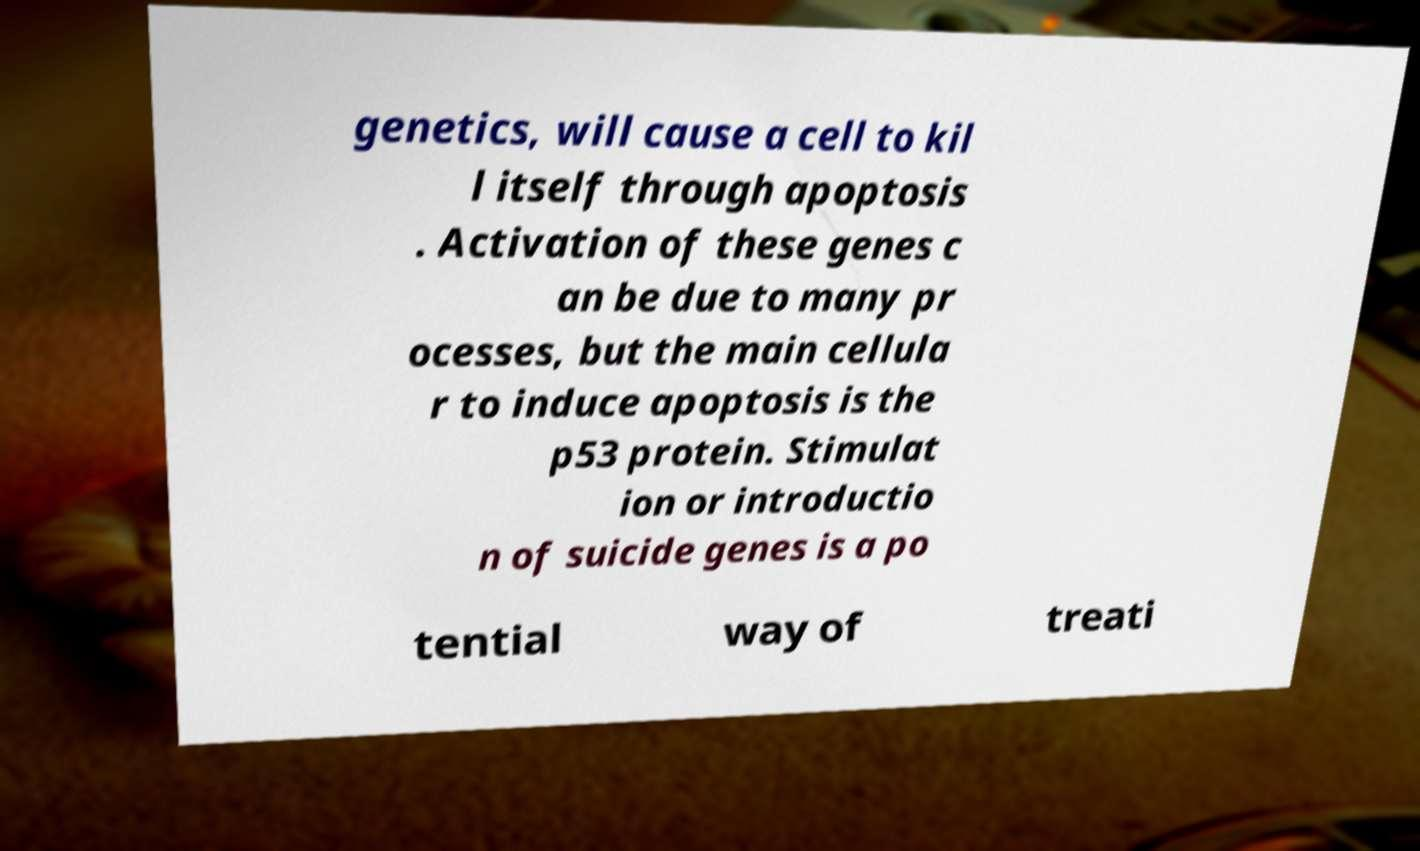Please read and relay the text visible in this image. What does it say? genetics, will cause a cell to kil l itself through apoptosis . Activation of these genes c an be due to many pr ocesses, but the main cellula r to induce apoptosis is the p53 protein. Stimulat ion or introductio n of suicide genes is a po tential way of treati 